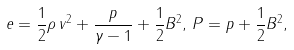<formula> <loc_0><loc_0><loc_500><loc_500>e = \frac { 1 } { 2 } \rho \, v ^ { 2 } + \frac { p } { \gamma - 1 } + \frac { 1 } { 2 } B ^ { 2 } , \, P = p + \frac { 1 } { 2 } B ^ { 2 } ,</formula> 